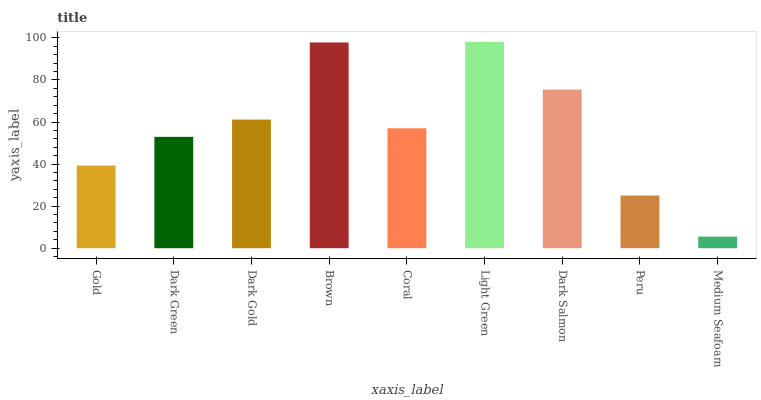Is Medium Seafoam the minimum?
Answer yes or no. Yes. Is Light Green the maximum?
Answer yes or no. Yes. Is Dark Green the minimum?
Answer yes or no. No. Is Dark Green the maximum?
Answer yes or no. No. Is Dark Green greater than Gold?
Answer yes or no. Yes. Is Gold less than Dark Green?
Answer yes or no. Yes. Is Gold greater than Dark Green?
Answer yes or no. No. Is Dark Green less than Gold?
Answer yes or no. No. Is Coral the high median?
Answer yes or no. Yes. Is Coral the low median?
Answer yes or no. Yes. Is Dark Gold the high median?
Answer yes or no. No. Is Brown the low median?
Answer yes or no. No. 